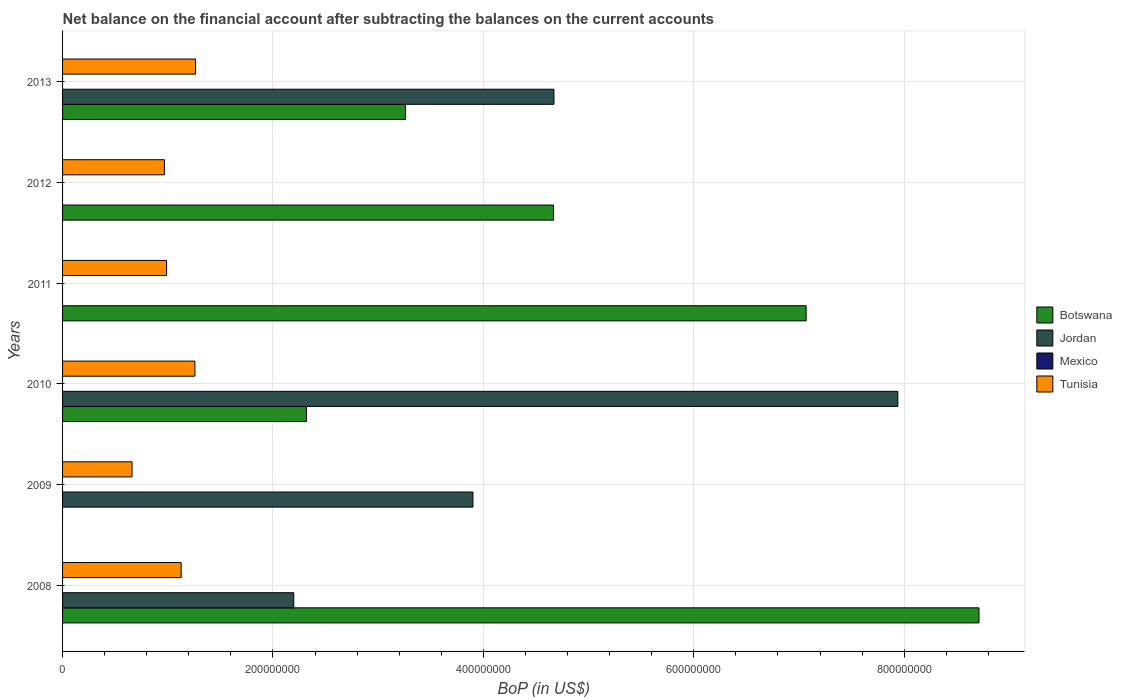How many groups of bars are there?
Provide a succinct answer. 6. How many bars are there on the 2nd tick from the top?
Your response must be concise. 2. How many bars are there on the 5th tick from the bottom?
Offer a terse response. 2. What is the Balance of Payments in Mexico in 2013?
Ensure brevity in your answer.  0. Across all years, what is the maximum Balance of Payments in Botswana?
Your response must be concise. 8.71e+08. Across all years, what is the minimum Balance of Payments in Jordan?
Keep it short and to the point. 0. In which year was the Balance of Payments in Tunisia maximum?
Make the answer very short. 2013. What is the total Balance of Payments in Jordan in the graph?
Offer a very short reply. 1.87e+09. What is the difference between the Balance of Payments in Tunisia in 2010 and that in 2013?
Give a very brief answer. -6.06e+05. What is the difference between the Balance of Payments in Jordan in 2009 and the Balance of Payments in Botswana in 2012?
Your answer should be very brief. -7.66e+07. What is the average Balance of Payments in Mexico per year?
Your response must be concise. 0. In the year 2010, what is the difference between the Balance of Payments in Botswana and Balance of Payments in Jordan?
Give a very brief answer. -5.62e+08. What is the ratio of the Balance of Payments in Botswana in 2008 to that in 2013?
Give a very brief answer. 2.67. What is the difference between the highest and the second highest Balance of Payments in Tunisia?
Ensure brevity in your answer.  6.06e+05. What is the difference between the highest and the lowest Balance of Payments in Botswana?
Your response must be concise. 8.71e+08. In how many years, is the Balance of Payments in Mexico greater than the average Balance of Payments in Mexico taken over all years?
Provide a succinct answer. 0. Is the sum of the Balance of Payments in Botswana in 2008 and 2013 greater than the maximum Balance of Payments in Tunisia across all years?
Offer a terse response. Yes. Is it the case that in every year, the sum of the Balance of Payments in Botswana and Balance of Payments in Tunisia is greater than the Balance of Payments in Jordan?
Your answer should be compact. No. What is the difference between two consecutive major ticks on the X-axis?
Your answer should be very brief. 2.00e+08. Are the values on the major ticks of X-axis written in scientific E-notation?
Provide a short and direct response. No. How are the legend labels stacked?
Your answer should be very brief. Vertical. What is the title of the graph?
Provide a succinct answer. Net balance on the financial account after subtracting the balances on the current accounts. Does "Seychelles" appear as one of the legend labels in the graph?
Provide a short and direct response. No. What is the label or title of the X-axis?
Provide a short and direct response. BoP (in US$). What is the BoP (in US$) in Botswana in 2008?
Your answer should be compact. 8.71e+08. What is the BoP (in US$) in Jordan in 2008?
Provide a succinct answer. 2.20e+08. What is the BoP (in US$) in Tunisia in 2008?
Keep it short and to the point. 1.13e+08. What is the BoP (in US$) in Jordan in 2009?
Make the answer very short. 3.90e+08. What is the BoP (in US$) in Tunisia in 2009?
Provide a short and direct response. 6.61e+07. What is the BoP (in US$) in Botswana in 2010?
Provide a short and direct response. 2.32e+08. What is the BoP (in US$) of Jordan in 2010?
Provide a short and direct response. 7.94e+08. What is the BoP (in US$) in Mexico in 2010?
Make the answer very short. 0. What is the BoP (in US$) in Tunisia in 2010?
Your response must be concise. 1.26e+08. What is the BoP (in US$) in Botswana in 2011?
Provide a succinct answer. 7.07e+08. What is the BoP (in US$) of Tunisia in 2011?
Keep it short and to the point. 9.89e+07. What is the BoP (in US$) in Botswana in 2012?
Offer a very short reply. 4.67e+08. What is the BoP (in US$) in Jordan in 2012?
Ensure brevity in your answer.  0. What is the BoP (in US$) of Mexico in 2012?
Provide a succinct answer. 0. What is the BoP (in US$) of Tunisia in 2012?
Keep it short and to the point. 9.68e+07. What is the BoP (in US$) in Botswana in 2013?
Ensure brevity in your answer.  3.26e+08. What is the BoP (in US$) in Jordan in 2013?
Offer a very short reply. 4.67e+08. What is the BoP (in US$) of Tunisia in 2013?
Make the answer very short. 1.26e+08. Across all years, what is the maximum BoP (in US$) in Botswana?
Make the answer very short. 8.71e+08. Across all years, what is the maximum BoP (in US$) of Jordan?
Ensure brevity in your answer.  7.94e+08. Across all years, what is the maximum BoP (in US$) of Tunisia?
Provide a succinct answer. 1.26e+08. Across all years, what is the minimum BoP (in US$) in Botswana?
Ensure brevity in your answer.  0. Across all years, what is the minimum BoP (in US$) of Jordan?
Your answer should be very brief. 0. Across all years, what is the minimum BoP (in US$) in Tunisia?
Make the answer very short. 6.61e+07. What is the total BoP (in US$) in Botswana in the graph?
Your answer should be very brief. 2.60e+09. What is the total BoP (in US$) in Jordan in the graph?
Your response must be concise. 1.87e+09. What is the total BoP (in US$) of Mexico in the graph?
Make the answer very short. 0. What is the total BoP (in US$) of Tunisia in the graph?
Keep it short and to the point. 6.27e+08. What is the difference between the BoP (in US$) in Jordan in 2008 and that in 2009?
Your answer should be very brief. -1.70e+08. What is the difference between the BoP (in US$) of Tunisia in 2008 and that in 2009?
Provide a succinct answer. 4.67e+07. What is the difference between the BoP (in US$) of Botswana in 2008 and that in 2010?
Ensure brevity in your answer.  6.39e+08. What is the difference between the BoP (in US$) in Jordan in 2008 and that in 2010?
Your answer should be very brief. -5.74e+08. What is the difference between the BoP (in US$) of Tunisia in 2008 and that in 2010?
Provide a succinct answer. -1.31e+07. What is the difference between the BoP (in US$) in Botswana in 2008 and that in 2011?
Your answer should be compact. 1.64e+08. What is the difference between the BoP (in US$) in Tunisia in 2008 and that in 2011?
Make the answer very short. 1.39e+07. What is the difference between the BoP (in US$) of Botswana in 2008 and that in 2012?
Offer a terse response. 4.04e+08. What is the difference between the BoP (in US$) in Tunisia in 2008 and that in 2012?
Your answer should be very brief. 1.59e+07. What is the difference between the BoP (in US$) in Botswana in 2008 and that in 2013?
Provide a succinct answer. 5.45e+08. What is the difference between the BoP (in US$) of Jordan in 2008 and that in 2013?
Keep it short and to the point. -2.47e+08. What is the difference between the BoP (in US$) in Tunisia in 2008 and that in 2013?
Your response must be concise. -1.37e+07. What is the difference between the BoP (in US$) in Jordan in 2009 and that in 2010?
Offer a terse response. -4.04e+08. What is the difference between the BoP (in US$) of Tunisia in 2009 and that in 2010?
Keep it short and to the point. -5.98e+07. What is the difference between the BoP (in US$) of Tunisia in 2009 and that in 2011?
Ensure brevity in your answer.  -3.28e+07. What is the difference between the BoP (in US$) of Tunisia in 2009 and that in 2012?
Give a very brief answer. -3.07e+07. What is the difference between the BoP (in US$) of Jordan in 2009 and that in 2013?
Your answer should be very brief. -7.70e+07. What is the difference between the BoP (in US$) in Tunisia in 2009 and that in 2013?
Your response must be concise. -6.04e+07. What is the difference between the BoP (in US$) in Botswana in 2010 and that in 2011?
Keep it short and to the point. -4.75e+08. What is the difference between the BoP (in US$) in Tunisia in 2010 and that in 2011?
Keep it short and to the point. 2.69e+07. What is the difference between the BoP (in US$) of Botswana in 2010 and that in 2012?
Make the answer very short. -2.35e+08. What is the difference between the BoP (in US$) in Tunisia in 2010 and that in 2012?
Make the answer very short. 2.90e+07. What is the difference between the BoP (in US$) of Botswana in 2010 and that in 2013?
Make the answer very short. -9.42e+07. What is the difference between the BoP (in US$) of Jordan in 2010 and that in 2013?
Offer a very short reply. 3.27e+08. What is the difference between the BoP (in US$) in Tunisia in 2010 and that in 2013?
Give a very brief answer. -6.06e+05. What is the difference between the BoP (in US$) in Botswana in 2011 and that in 2012?
Keep it short and to the point. 2.40e+08. What is the difference between the BoP (in US$) in Tunisia in 2011 and that in 2012?
Offer a terse response. 2.07e+06. What is the difference between the BoP (in US$) of Botswana in 2011 and that in 2013?
Offer a very short reply. 3.81e+08. What is the difference between the BoP (in US$) in Tunisia in 2011 and that in 2013?
Keep it short and to the point. -2.75e+07. What is the difference between the BoP (in US$) of Botswana in 2012 and that in 2013?
Offer a very short reply. 1.41e+08. What is the difference between the BoP (in US$) in Tunisia in 2012 and that in 2013?
Your answer should be compact. -2.96e+07. What is the difference between the BoP (in US$) of Botswana in 2008 and the BoP (in US$) of Jordan in 2009?
Your answer should be compact. 4.81e+08. What is the difference between the BoP (in US$) in Botswana in 2008 and the BoP (in US$) in Tunisia in 2009?
Your answer should be compact. 8.05e+08. What is the difference between the BoP (in US$) in Jordan in 2008 and the BoP (in US$) in Tunisia in 2009?
Give a very brief answer. 1.54e+08. What is the difference between the BoP (in US$) in Botswana in 2008 and the BoP (in US$) in Jordan in 2010?
Offer a very short reply. 7.72e+07. What is the difference between the BoP (in US$) in Botswana in 2008 and the BoP (in US$) in Tunisia in 2010?
Offer a terse response. 7.45e+08. What is the difference between the BoP (in US$) of Jordan in 2008 and the BoP (in US$) of Tunisia in 2010?
Make the answer very short. 9.40e+07. What is the difference between the BoP (in US$) of Botswana in 2008 and the BoP (in US$) of Tunisia in 2011?
Give a very brief answer. 7.72e+08. What is the difference between the BoP (in US$) in Jordan in 2008 and the BoP (in US$) in Tunisia in 2011?
Provide a succinct answer. 1.21e+08. What is the difference between the BoP (in US$) of Botswana in 2008 and the BoP (in US$) of Tunisia in 2012?
Offer a very short reply. 7.74e+08. What is the difference between the BoP (in US$) of Jordan in 2008 and the BoP (in US$) of Tunisia in 2012?
Give a very brief answer. 1.23e+08. What is the difference between the BoP (in US$) of Botswana in 2008 and the BoP (in US$) of Jordan in 2013?
Give a very brief answer. 4.04e+08. What is the difference between the BoP (in US$) of Botswana in 2008 and the BoP (in US$) of Tunisia in 2013?
Provide a succinct answer. 7.45e+08. What is the difference between the BoP (in US$) of Jordan in 2008 and the BoP (in US$) of Tunisia in 2013?
Make the answer very short. 9.33e+07. What is the difference between the BoP (in US$) of Jordan in 2009 and the BoP (in US$) of Tunisia in 2010?
Your response must be concise. 2.64e+08. What is the difference between the BoP (in US$) of Jordan in 2009 and the BoP (in US$) of Tunisia in 2011?
Make the answer very short. 2.91e+08. What is the difference between the BoP (in US$) of Jordan in 2009 and the BoP (in US$) of Tunisia in 2012?
Provide a short and direct response. 2.93e+08. What is the difference between the BoP (in US$) in Jordan in 2009 and the BoP (in US$) in Tunisia in 2013?
Ensure brevity in your answer.  2.64e+08. What is the difference between the BoP (in US$) in Botswana in 2010 and the BoP (in US$) in Tunisia in 2011?
Make the answer very short. 1.33e+08. What is the difference between the BoP (in US$) in Jordan in 2010 and the BoP (in US$) in Tunisia in 2011?
Ensure brevity in your answer.  6.95e+08. What is the difference between the BoP (in US$) in Botswana in 2010 and the BoP (in US$) in Tunisia in 2012?
Provide a short and direct response. 1.35e+08. What is the difference between the BoP (in US$) in Jordan in 2010 and the BoP (in US$) in Tunisia in 2012?
Your answer should be compact. 6.97e+08. What is the difference between the BoP (in US$) in Botswana in 2010 and the BoP (in US$) in Jordan in 2013?
Keep it short and to the point. -2.35e+08. What is the difference between the BoP (in US$) of Botswana in 2010 and the BoP (in US$) of Tunisia in 2013?
Keep it short and to the point. 1.05e+08. What is the difference between the BoP (in US$) in Jordan in 2010 and the BoP (in US$) in Tunisia in 2013?
Make the answer very short. 6.68e+08. What is the difference between the BoP (in US$) in Botswana in 2011 and the BoP (in US$) in Tunisia in 2012?
Ensure brevity in your answer.  6.10e+08. What is the difference between the BoP (in US$) in Botswana in 2011 and the BoP (in US$) in Jordan in 2013?
Your response must be concise. 2.40e+08. What is the difference between the BoP (in US$) of Botswana in 2011 and the BoP (in US$) of Tunisia in 2013?
Ensure brevity in your answer.  5.80e+08. What is the difference between the BoP (in US$) in Botswana in 2012 and the BoP (in US$) in Jordan in 2013?
Offer a very short reply. -4.16e+05. What is the difference between the BoP (in US$) of Botswana in 2012 and the BoP (in US$) of Tunisia in 2013?
Give a very brief answer. 3.40e+08. What is the average BoP (in US$) of Botswana per year?
Make the answer very short. 4.34e+08. What is the average BoP (in US$) of Jordan per year?
Provide a succinct answer. 3.12e+08. What is the average BoP (in US$) in Mexico per year?
Provide a succinct answer. 0. What is the average BoP (in US$) of Tunisia per year?
Give a very brief answer. 1.04e+08. In the year 2008, what is the difference between the BoP (in US$) of Botswana and BoP (in US$) of Jordan?
Your response must be concise. 6.51e+08. In the year 2008, what is the difference between the BoP (in US$) in Botswana and BoP (in US$) in Tunisia?
Keep it short and to the point. 7.58e+08. In the year 2008, what is the difference between the BoP (in US$) in Jordan and BoP (in US$) in Tunisia?
Offer a very short reply. 1.07e+08. In the year 2009, what is the difference between the BoP (in US$) in Jordan and BoP (in US$) in Tunisia?
Your response must be concise. 3.24e+08. In the year 2010, what is the difference between the BoP (in US$) in Botswana and BoP (in US$) in Jordan?
Provide a short and direct response. -5.62e+08. In the year 2010, what is the difference between the BoP (in US$) of Botswana and BoP (in US$) of Tunisia?
Offer a very short reply. 1.06e+08. In the year 2010, what is the difference between the BoP (in US$) in Jordan and BoP (in US$) in Tunisia?
Offer a very short reply. 6.68e+08. In the year 2011, what is the difference between the BoP (in US$) of Botswana and BoP (in US$) of Tunisia?
Offer a terse response. 6.08e+08. In the year 2012, what is the difference between the BoP (in US$) of Botswana and BoP (in US$) of Tunisia?
Offer a very short reply. 3.70e+08. In the year 2013, what is the difference between the BoP (in US$) in Botswana and BoP (in US$) in Jordan?
Give a very brief answer. -1.41e+08. In the year 2013, what is the difference between the BoP (in US$) in Botswana and BoP (in US$) in Tunisia?
Your response must be concise. 2.00e+08. In the year 2013, what is the difference between the BoP (in US$) of Jordan and BoP (in US$) of Tunisia?
Your answer should be very brief. 3.41e+08. What is the ratio of the BoP (in US$) in Jordan in 2008 to that in 2009?
Offer a terse response. 0.56. What is the ratio of the BoP (in US$) in Tunisia in 2008 to that in 2009?
Make the answer very short. 1.71. What is the ratio of the BoP (in US$) in Botswana in 2008 to that in 2010?
Your answer should be very brief. 3.76. What is the ratio of the BoP (in US$) of Jordan in 2008 to that in 2010?
Your answer should be compact. 0.28. What is the ratio of the BoP (in US$) of Tunisia in 2008 to that in 2010?
Offer a terse response. 0.9. What is the ratio of the BoP (in US$) in Botswana in 2008 to that in 2011?
Make the answer very short. 1.23. What is the ratio of the BoP (in US$) in Tunisia in 2008 to that in 2011?
Your response must be concise. 1.14. What is the ratio of the BoP (in US$) in Botswana in 2008 to that in 2012?
Ensure brevity in your answer.  1.87. What is the ratio of the BoP (in US$) in Tunisia in 2008 to that in 2012?
Offer a terse response. 1.16. What is the ratio of the BoP (in US$) in Botswana in 2008 to that in 2013?
Give a very brief answer. 2.67. What is the ratio of the BoP (in US$) in Jordan in 2008 to that in 2013?
Provide a short and direct response. 0.47. What is the ratio of the BoP (in US$) of Tunisia in 2008 to that in 2013?
Ensure brevity in your answer.  0.89. What is the ratio of the BoP (in US$) of Jordan in 2009 to that in 2010?
Make the answer very short. 0.49. What is the ratio of the BoP (in US$) of Tunisia in 2009 to that in 2010?
Your answer should be very brief. 0.53. What is the ratio of the BoP (in US$) of Tunisia in 2009 to that in 2011?
Ensure brevity in your answer.  0.67. What is the ratio of the BoP (in US$) of Tunisia in 2009 to that in 2012?
Your answer should be compact. 0.68. What is the ratio of the BoP (in US$) of Jordan in 2009 to that in 2013?
Your answer should be very brief. 0.84. What is the ratio of the BoP (in US$) of Tunisia in 2009 to that in 2013?
Make the answer very short. 0.52. What is the ratio of the BoP (in US$) of Botswana in 2010 to that in 2011?
Offer a terse response. 0.33. What is the ratio of the BoP (in US$) of Tunisia in 2010 to that in 2011?
Make the answer very short. 1.27. What is the ratio of the BoP (in US$) in Botswana in 2010 to that in 2012?
Ensure brevity in your answer.  0.5. What is the ratio of the BoP (in US$) of Tunisia in 2010 to that in 2012?
Provide a succinct answer. 1.3. What is the ratio of the BoP (in US$) in Botswana in 2010 to that in 2013?
Your response must be concise. 0.71. What is the ratio of the BoP (in US$) in Jordan in 2010 to that in 2013?
Provide a short and direct response. 1.7. What is the ratio of the BoP (in US$) in Tunisia in 2010 to that in 2013?
Offer a very short reply. 1. What is the ratio of the BoP (in US$) of Botswana in 2011 to that in 2012?
Provide a succinct answer. 1.51. What is the ratio of the BoP (in US$) in Tunisia in 2011 to that in 2012?
Your answer should be very brief. 1.02. What is the ratio of the BoP (in US$) of Botswana in 2011 to that in 2013?
Your response must be concise. 2.17. What is the ratio of the BoP (in US$) in Tunisia in 2011 to that in 2013?
Make the answer very short. 0.78. What is the ratio of the BoP (in US$) in Botswana in 2012 to that in 2013?
Provide a succinct answer. 1.43. What is the ratio of the BoP (in US$) of Tunisia in 2012 to that in 2013?
Your answer should be compact. 0.77. What is the difference between the highest and the second highest BoP (in US$) in Botswana?
Your answer should be very brief. 1.64e+08. What is the difference between the highest and the second highest BoP (in US$) of Jordan?
Your response must be concise. 3.27e+08. What is the difference between the highest and the second highest BoP (in US$) of Tunisia?
Provide a short and direct response. 6.06e+05. What is the difference between the highest and the lowest BoP (in US$) of Botswana?
Your response must be concise. 8.71e+08. What is the difference between the highest and the lowest BoP (in US$) in Jordan?
Your answer should be very brief. 7.94e+08. What is the difference between the highest and the lowest BoP (in US$) in Tunisia?
Make the answer very short. 6.04e+07. 